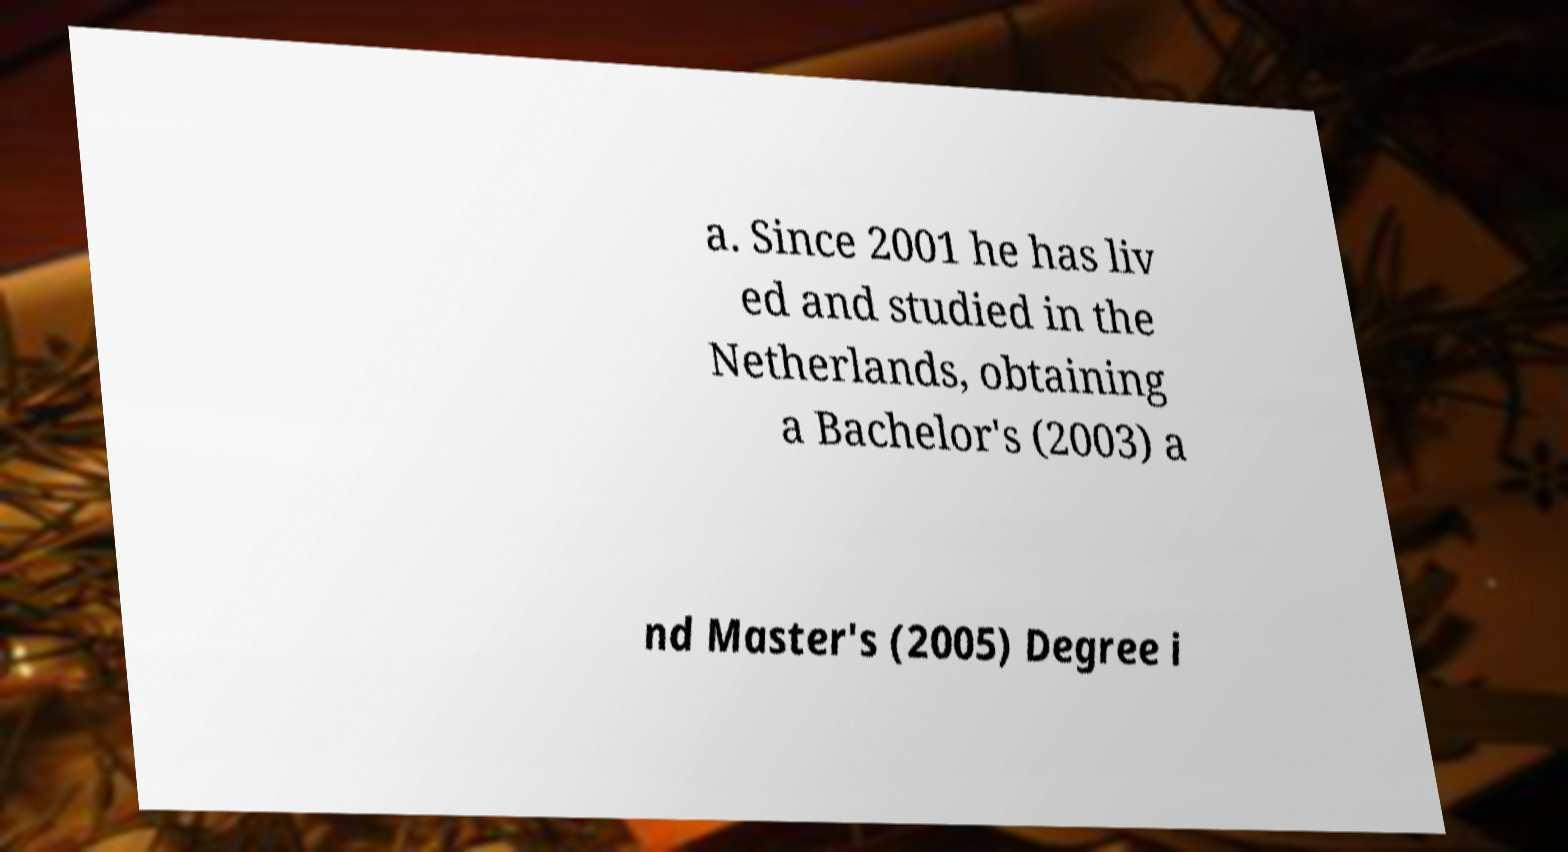What messages or text are displayed in this image? I need them in a readable, typed format. a. Since 2001 he has liv ed and studied in the Netherlands, obtaining a Bachelor's (2003) a nd Master's (2005) Degree i 